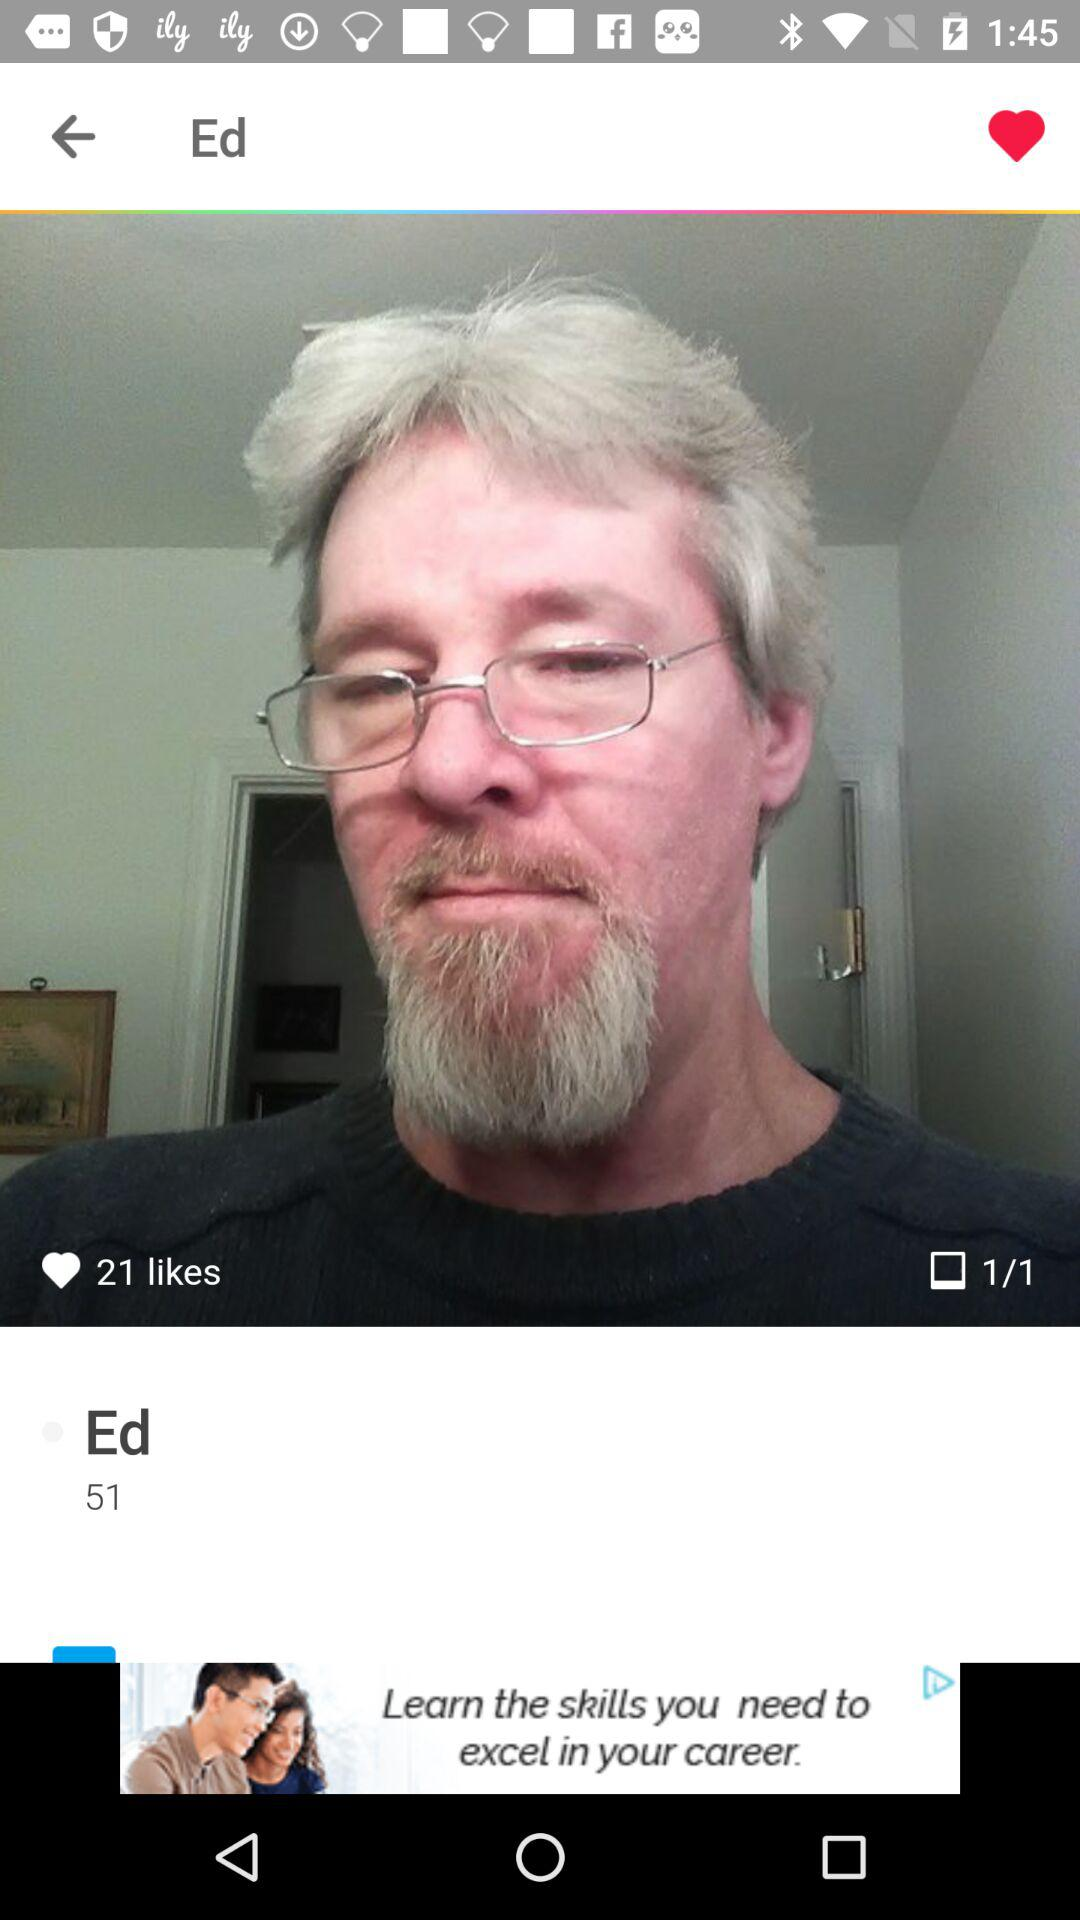How many likes are there of the image? There are 21 likes of the image. 